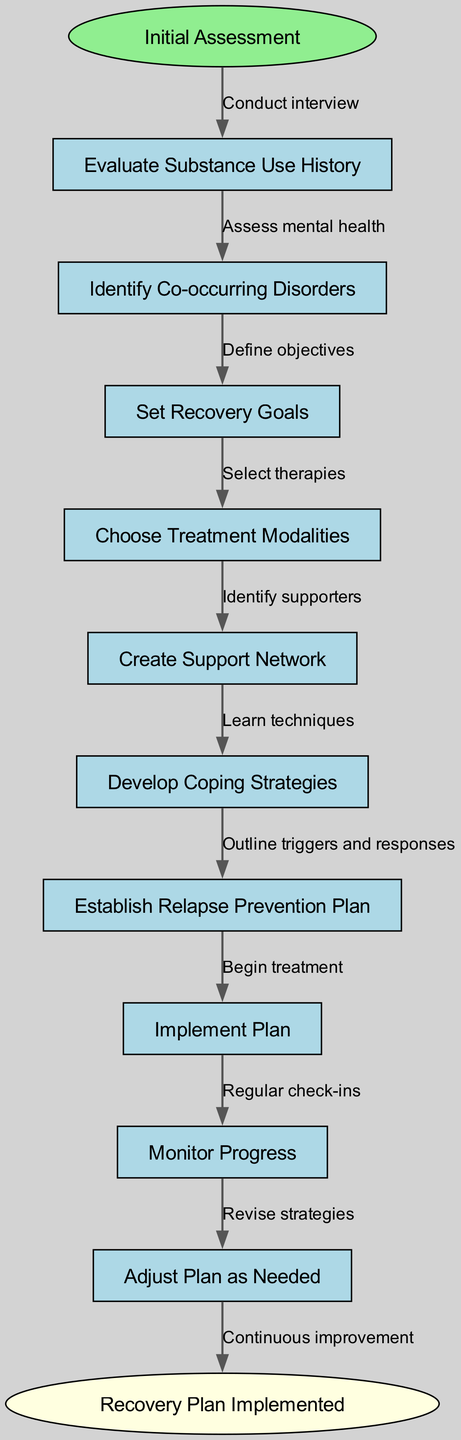What is the starting node of the flowchart? The diagram indicates that the flowchart begins with the node labeled "Initial Assessment." This is found at the top and is marked distinctly as the start of the process.
Answer: Initial Assessment How many nodes are present in the diagram? Counting the nodes listed in the diagram, there are a total of ten nodes, including the starting and ending nodes. This includes "Initial Assessment" and "Recovery Plan Implemented."
Answer: 10 What is the edge leading from "Evaluate Substance Use History"? The edge leading from "Evaluate Substance Use History" is labeled "Conduct interview," which connects this node to the first step in the process.
Answer: Conduct interview Which node comes after "Set Recovery Goals"? The next node after "Set Recovery Goals" is "Choose Treatment Modalities," which follows the specified flow of the diagram.
Answer: Choose Treatment Modalities What is the final node of the flowchart? The last node of the flowchart is labeled "Recovery Plan Implemented." This node signifies the conclusion of the process, showing the final outcome once the entire plan is completed.
Answer: Recovery Plan Implemented Which two nodes are connected by the edge labeled "Learn techniques"? The edge labeled "Learn techniques" connects the nodes "Develop Coping Strategies" and "Establish Relapse Prevention Plan." This illustrates a sequential step in the recovery plan.
Answer: Develop Coping Strategies and Establish Relapse Prevention Plan What signifies the continuous improvement aspect in the diagram? The notion of continuous improvement is represented by the edge that states "Continuous improvement," which connects the last processing node to the endpoint of the flowchart, indicating the ongoing nature of recovery.
Answer: Continuous improvement What type of strategies are developed after "Create Support Network"? The strategies developed after "Create Support Network" are "Develop Coping Strategies," representing the logical progression in the addiction recovery plan.
Answer: Develop Coping Strategies Which node has the most connections? The node "Establish Relapse Prevention Plan" doesn't have the highest number of connections; rather, all nodes are connected sequentially. However, the final node is connected to the "Establish Relapse Prevention Plan" through "Outline triggers and responses." Therefore, no node stands out for having multiple connections.
Answer: None 